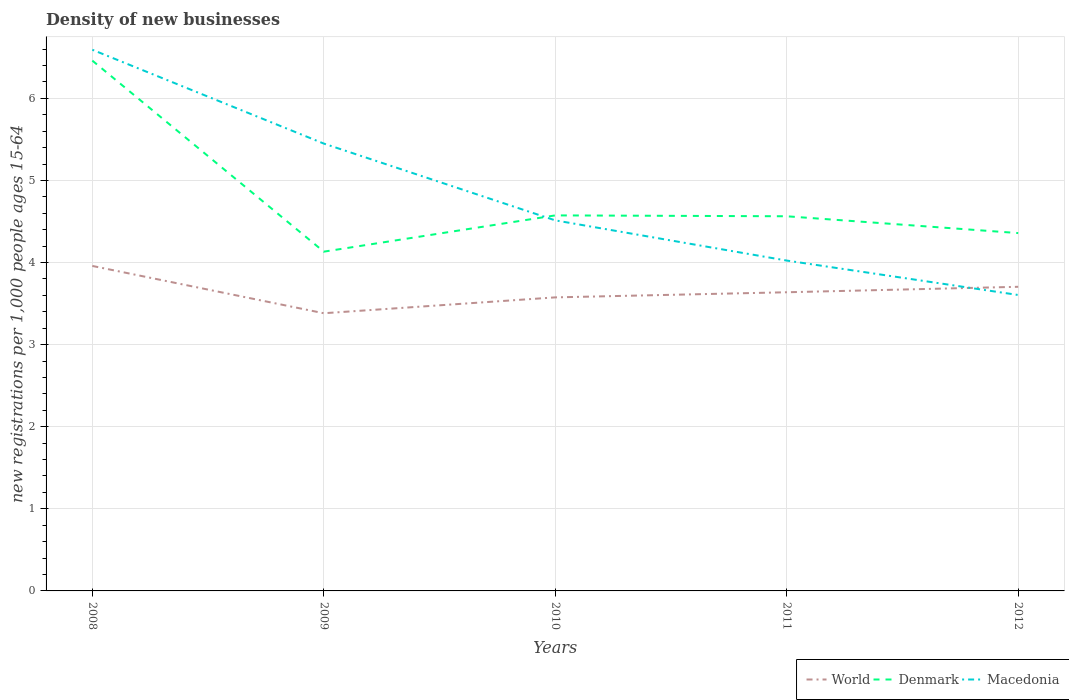How many different coloured lines are there?
Offer a terse response. 3. Does the line corresponding to World intersect with the line corresponding to Denmark?
Give a very brief answer. No. Is the number of lines equal to the number of legend labels?
Provide a succinct answer. Yes. Across all years, what is the maximum number of new registrations in World?
Provide a short and direct response. 3.38. In which year was the number of new registrations in Denmark maximum?
Your answer should be very brief. 2009. What is the total number of new registrations in Denmark in the graph?
Offer a very short reply. -0.23. What is the difference between the highest and the second highest number of new registrations in Denmark?
Keep it short and to the point. 2.33. What is the difference between the highest and the lowest number of new registrations in Macedonia?
Your answer should be compact. 2. What is the difference between two consecutive major ticks on the Y-axis?
Provide a short and direct response. 1. Are the values on the major ticks of Y-axis written in scientific E-notation?
Provide a succinct answer. No. Does the graph contain grids?
Keep it short and to the point. Yes. Where does the legend appear in the graph?
Provide a short and direct response. Bottom right. How many legend labels are there?
Offer a very short reply. 3. What is the title of the graph?
Make the answer very short. Density of new businesses. What is the label or title of the Y-axis?
Your answer should be very brief. New registrations per 1,0 people ages 15-64. What is the new registrations per 1,000 people ages 15-64 of World in 2008?
Provide a short and direct response. 3.96. What is the new registrations per 1,000 people ages 15-64 in Denmark in 2008?
Make the answer very short. 6.46. What is the new registrations per 1,000 people ages 15-64 of Macedonia in 2008?
Offer a terse response. 6.59. What is the new registrations per 1,000 people ages 15-64 in World in 2009?
Give a very brief answer. 3.38. What is the new registrations per 1,000 people ages 15-64 in Denmark in 2009?
Ensure brevity in your answer.  4.13. What is the new registrations per 1,000 people ages 15-64 of Macedonia in 2009?
Your response must be concise. 5.45. What is the new registrations per 1,000 people ages 15-64 of World in 2010?
Provide a succinct answer. 3.58. What is the new registrations per 1,000 people ages 15-64 in Denmark in 2010?
Keep it short and to the point. 4.57. What is the new registrations per 1,000 people ages 15-64 of Macedonia in 2010?
Offer a terse response. 4.51. What is the new registrations per 1,000 people ages 15-64 in World in 2011?
Give a very brief answer. 3.64. What is the new registrations per 1,000 people ages 15-64 of Denmark in 2011?
Provide a short and direct response. 4.56. What is the new registrations per 1,000 people ages 15-64 of Macedonia in 2011?
Your answer should be very brief. 4.02. What is the new registrations per 1,000 people ages 15-64 in World in 2012?
Give a very brief answer. 3.7. What is the new registrations per 1,000 people ages 15-64 in Denmark in 2012?
Offer a terse response. 4.36. What is the new registrations per 1,000 people ages 15-64 in Macedonia in 2012?
Your response must be concise. 3.6. Across all years, what is the maximum new registrations per 1,000 people ages 15-64 of World?
Make the answer very short. 3.96. Across all years, what is the maximum new registrations per 1,000 people ages 15-64 of Denmark?
Provide a short and direct response. 6.46. Across all years, what is the maximum new registrations per 1,000 people ages 15-64 of Macedonia?
Your answer should be very brief. 6.59. Across all years, what is the minimum new registrations per 1,000 people ages 15-64 in World?
Your answer should be compact. 3.38. Across all years, what is the minimum new registrations per 1,000 people ages 15-64 in Denmark?
Provide a succinct answer. 4.13. Across all years, what is the minimum new registrations per 1,000 people ages 15-64 of Macedonia?
Provide a succinct answer. 3.6. What is the total new registrations per 1,000 people ages 15-64 of World in the graph?
Offer a very short reply. 18.26. What is the total new registrations per 1,000 people ages 15-64 of Denmark in the graph?
Ensure brevity in your answer.  24.09. What is the total new registrations per 1,000 people ages 15-64 of Macedonia in the graph?
Ensure brevity in your answer.  24.18. What is the difference between the new registrations per 1,000 people ages 15-64 of World in 2008 and that in 2009?
Give a very brief answer. 0.58. What is the difference between the new registrations per 1,000 people ages 15-64 in Denmark in 2008 and that in 2009?
Provide a succinct answer. 2.33. What is the difference between the new registrations per 1,000 people ages 15-64 of Macedonia in 2008 and that in 2009?
Your answer should be compact. 1.14. What is the difference between the new registrations per 1,000 people ages 15-64 of World in 2008 and that in 2010?
Keep it short and to the point. 0.38. What is the difference between the new registrations per 1,000 people ages 15-64 of Denmark in 2008 and that in 2010?
Provide a succinct answer. 1.89. What is the difference between the new registrations per 1,000 people ages 15-64 in Macedonia in 2008 and that in 2010?
Make the answer very short. 2.08. What is the difference between the new registrations per 1,000 people ages 15-64 of World in 2008 and that in 2011?
Offer a very short reply. 0.32. What is the difference between the new registrations per 1,000 people ages 15-64 of Denmark in 2008 and that in 2011?
Give a very brief answer. 1.9. What is the difference between the new registrations per 1,000 people ages 15-64 in Macedonia in 2008 and that in 2011?
Offer a very short reply. 2.57. What is the difference between the new registrations per 1,000 people ages 15-64 in World in 2008 and that in 2012?
Keep it short and to the point. 0.25. What is the difference between the new registrations per 1,000 people ages 15-64 of Denmark in 2008 and that in 2012?
Provide a succinct answer. 2.1. What is the difference between the new registrations per 1,000 people ages 15-64 in Macedonia in 2008 and that in 2012?
Ensure brevity in your answer.  2.99. What is the difference between the new registrations per 1,000 people ages 15-64 of World in 2009 and that in 2010?
Offer a very short reply. -0.19. What is the difference between the new registrations per 1,000 people ages 15-64 of Denmark in 2009 and that in 2010?
Offer a very short reply. -0.44. What is the difference between the new registrations per 1,000 people ages 15-64 of Macedonia in 2009 and that in 2010?
Offer a very short reply. 0.94. What is the difference between the new registrations per 1,000 people ages 15-64 of World in 2009 and that in 2011?
Offer a terse response. -0.26. What is the difference between the new registrations per 1,000 people ages 15-64 in Denmark in 2009 and that in 2011?
Offer a terse response. -0.43. What is the difference between the new registrations per 1,000 people ages 15-64 of Macedonia in 2009 and that in 2011?
Offer a very short reply. 1.43. What is the difference between the new registrations per 1,000 people ages 15-64 in World in 2009 and that in 2012?
Keep it short and to the point. -0.32. What is the difference between the new registrations per 1,000 people ages 15-64 of Denmark in 2009 and that in 2012?
Offer a terse response. -0.23. What is the difference between the new registrations per 1,000 people ages 15-64 in Macedonia in 2009 and that in 2012?
Your response must be concise. 1.84. What is the difference between the new registrations per 1,000 people ages 15-64 in World in 2010 and that in 2011?
Offer a very short reply. -0.06. What is the difference between the new registrations per 1,000 people ages 15-64 of Denmark in 2010 and that in 2011?
Provide a short and direct response. 0.01. What is the difference between the new registrations per 1,000 people ages 15-64 in Macedonia in 2010 and that in 2011?
Keep it short and to the point. 0.49. What is the difference between the new registrations per 1,000 people ages 15-64 in World in 2010 and that in 2012?
Keep it short and to the point. -0.13. What is the difference between the new registrations per 1,000 people ages 15-64 of Denmark in 2010 and that in 2012?
Your answer should be compact. 0.22. What is the difference between the new registrations per 1,000 people ages 15-64 of Macedonia in 2010 and that in 2012?
Keep it short and to the point. 0.91. What is the difference between the new registrations per 1,000 people ages 15-64 of World in 2011 and that in 2012?
Your response must be concise. -0.07. What is the difference between the new registrations per 1,000 people ages 15-64 in Denmark in 2011 and that in 2012?
Give a very brief answer. 0.2. What is the difference between the new registrations per 1,000 people ages 15-64 of Macedonia in 2011 and that in 2012?
Your response must be concise. 0.42. What is the difference between the new registrations per 1,000 people ages 15-64 of World in 2008 and the new registrations per 1,000 people ages 15-64 of Denmark in 2009?
Provide a short and direct response. -0.17. What is the difference between the new registrations per 1,000 people ages 15-64 in World in 2008 and the new registrations per 1,000 people ages 15-64 in Macedonia in 2009?
Offer a very short reply. -1.49. What is the difference between the new registrations per 1,000 people ages 15-64 in Denmark in 2008 and the new registrations per 1,000 people ages 15-64 in Macedonia in 2009?
Keep it short and to the point. 1.01. What is the difference between the new registrations per 1,000 people ages 15-64 in World in 2008 and the new registrations per 1,000 people ages 15-64 in Denmark in 2010?
Your answer should be compact. -0.62. What is the difference between the new registrations per 1,000 people ages 15-64 in World in 2008 and the new registrations per 1,000 people ages 15-64 in Macedonia in 2010?
Make the answer very short. -0.56. What is the difference between the new registrations per 1,000 people ages 15-64 in Denmark in 2008 and the new registrations per 1,000 people ages 15-64 in Macedonia in 2010?
Give a very brief answer. 1.95. What is the difference between the new registrations per 1,000 people ages 15-64 in World in 2008 and the new registrations per 1,000 people ages 15-64 in Denmark in 2011?
Offer a terse response. -0.6. What is the difference between the new registrations per 1,000 people ages 15-64 in World in 2008 and the new registrations per 1,000 people ages 15-64 in Macedonia in 2011?
Your answer should be compact. -0.07. What is the difference between the new registrations per 1,000 people ages 15-64 of Denmark in 2008 and the new registrations per 1,000 people ages 15-64 of Macedonia in 2011?
Give a very brief answer. 2.44. What is the difference between the new registrations per 1,000 people ages 15-64 in World in 2008 and the new registrations per 1,000 people ages 15-64 in Denmark in 2012?
Provide a succinct answer. -0.4. What is the difference between the new registrations per 1,000 people ages 15-64 in World in 2008 and the new registrations per 1,000 people ages 15-64 in Macedonia in 2012?
Give a very brief answer. 0.35. What is the difference between the new registrations per 1,000 people ages 15-64 of Denmark in 2008 and the new registrations per 1,000 people ages 15-64 of Macedonia in 2012?
Offer a terse response. 2.86. What is the difference between the new registrations per 1,000 people ages 15-64 of World in 2009 and the new registrations per 1,000 people ages 15-64 of Denmark in 2010?
Your response must be concise. -1.19. What is the difference between the new registrations per 1,000 people ages 15-64 of World in 2009 and the new registrations per 1,000 people ages 15-64 of Macedonia in 2010?
Offer a very short reply. -1.13. What is the difference between the new registrations per 1,000 people ages 15-64 in Denmark in 2009 and the new registrations per 1,000 people ages 15-64 in Macedonia in 2010?
Make the answer very short. -0.38. What is the difference between the new registrations per 1,000 people ages 15-64 in World in 2009 and the new registrations per 1,000 people ages 15-64 in Denmark in 2011?
Offer a terse response. -1.18. What is the difference between the new registrations per 1,000 people ages 15-64 of World in 2009 and the new registrations per 1,000 people ages 15-64 of Macedonia in 2011?
Offer a terse response. -0.64. What is the difference between the new registrations per 1,000 people ages 15-64 of Denmark in 2009 and the new registrations per 1,000 people ages 15-64 of Macedonia in 2011?
Your response must be concise. 0.11. What is the difference between the new registrations per 1,000 people ages 15-64 of World in 2009 and the new registrations per 1,000 people ages 15-64 of Denmark in 2012?
Provide a succinct answer. -0.98. What is the difference between the new registrations per 1,000 people ages 15-64 in World in 2009 and the new registrations per 1,000 people ages 15-64 in Macedonia in 2012?
Offer a terse response. -0.22. What is the difference between the new registrations per 1,000 people ages 15-64 of Denmark in 2009 and the new registrations per 1,000 people ages 15-64 of Macedonia in 2012?
Give a very brief answer. 0.53. What is the difference between the new registrations per 1,000 people ages 15-64 in World in 2010 and the new registrations per 1,000 people ages 15-64 in Denmark in 2011?
Provide a short and direct response. -0.99. What is the difference between the new registrations per 1,000 people ages 15-64 in World in 2010 and the new registrations per 1,000 people ages 15-64 in Macedonia in 2011?
Keep it short and to the point. -0.45. What is the difference between the new registrations per 1,000 people ages 15-64 of Denmark in 2010 and the new registrations per 1,000 people ages 15-64 of Macedonia in 2011?
Provide a short and direct response. 0.55. What is the difference between the new registrations per 1,000 people ages 15-64 in World in 2010 and the new registrations per 1,000 people ages 15-64 in Denmark in 2012?
Keep it short and to the point. -0.78. What is the difference between the new registrations per 1,000 people ages 15-64 in World in 2010 and the new registrations per 1,000 people ages 15-64 in Macedonia in 2012?
Ensure brevity in your answer.  -0.03. What is the difference between the new registrations per 1,000 people ages 15-64 of Denmark in 2010 and the new registrations per 1,000 people ages 15-64 of Macedonia in 2012?
Offer a terse response. 0.97. What is the difference between the new registrations per 1,000 people ages 15-64 of World in 2011 and the new registrations per 1,000 people ages 15-64 of Denmark in 2012?
Offer a very short reply. -0.72. What is the difference between the new registrations per 1,000 people ages 15-64 of Denmark in 2011 and the new registrations per 1,000 people ages 15-64 of Macedonia in 2012?
Your answer should be very brief. 0.96. What is the average new registrations per 1,000 people ages 15-64 in World per year?
Give a very brief answer. 3.65. What is the average new registrations per 1,000 people ages 15-64 of Denmark per year?
Give a very brief answer. 4.82. What is the average new registrations per 1,000 people ages 15-64 of Macedonia per year?
Offer a terse response. 4.84. In the year 2008, what is the difference between the new registrations per 1,000 people ages 15-64 of World and new registrations per 1,000 people ages 15-64 of Denmark?
Provide a succinct answer. -2.5. In the year 2008, what is the difference between the new registrations per 1,000 people ages 15-64 in World and new registrations per 1,000 people ages 15-64 in Macedonia?
Ensure brevity in your answer.  -2.63. In the year 2008, what is the difference between the new registrations per 1,000 people ages 15-64 of Denmark and new registrations per 1,000 people ages 15-64 of Macedonia?
Your response must be concise. -0.13. In the year 2009, what is the difference between the new registrations per 1,000 people ages 15-64 in World and new registrations per 1,000 people ages 15-64 in Denmark?
Your answer should be very brief. -0.75. In the year 2009, what is the difference between the new registrations per 1,000 people ages 15-64 of World and new registrations per 1,000 people ages 15-64 of Macedonia?
Offer a very short reply. -2.07. In the year 2009, what is the difference between the new registrations per 1,000 people ages 15-64 in Denmark and new registrations per 1,000 people ages 15-64 in Macedonia?
Provide a short and direct response. -1.32. In the year 2010, what is the difference between the new registrations per 1,000 people ages 15-64 of World and new registrations per 1,000 people ages 15-64 of Denmark?
Give a very brief answer. -1. In the year 2010, what is the difference between the new registrations per 1,000 people ages 15-64 of World and new registrations per 1,000 people ages 15-64 of Macedonia?
Offer a terse response. -0.94. In the year 2010, what is the difference between the new registrations per 1,000 people ages 15-64 in Denmark and new registrations per 1,000 people ages 15-64 in Macedonia?
Make the answer very short. 0.06. In the year 2011, what is the difference between the new registrations per 1,000 people ages 15-64 in World and new registrations per 1,000 people ages 15-64 in Denmark?
Your response must be concise. -0.93. In the year 2011, what is the difference between the new registrations per 1,000 people ages 15-64 of World and new registrations per 1,000 people ages 15-64 of Macedonia?
Provide a short and direct response. -0.39. In the year 2011, what is the difference between the new registrations per 1,000 people ages 15-64 of Denmark and new registrations per 1,000 people ages 15-64 of Macedonia?
Offer a terse response. 0.54. In the year 2012, what is the difference between the new registrations per 1,000 people ages 15-64 of World and new registrations per 1,000 people ages 15-64 of Denmark?
Provide a succinct answer. -0.65. In the year 2012, what is the difference between the new registrations per 1,000 people ages 15-64 of Denmark and new registrations per 1,000 people ages 15-64 of Macedonia?
Ensure brevity in your answer.  0.75. What is the ratio of the new registrations per 1,000 people ages 15-64 in World in 2008 to that in 2009?
Your response must be concise. 1.17. What is the ratio of the new registrations per 1,000 people ages 15-64 of Denmark in 2008 to that in 2009?
Your answer should be very brief. 1.56. What is the ratio of the new registrations per 1,000 people ages 15-64 of Macedonia in 2008 to that in 2009?
Provide a succinct answer. 1.21. What is the ratio of the new registrations per 1,000 people ages 15-64 of World in 2008 to that in 2010?
Provide a succinct answer. 1.11. What is the ratio of the new registrations per 1,000 people ages 15-64 in Denmark in 2008 to that in 2010?
Provide a short and direct response. 1.41. What is the ratio of the new registrations per 1,000 people ages 15-64 of Macedonia in 2008 to that in 2010?
Provide a short and direct response. 1.46. What is the ratio of the new registrations per 1,000 people ages 15-64 in World in 2008 to that in 2011?
Make the answer very short. 1.09. What is the ratio of the new registrations per 1,000 people ages 15-64 of Denmark in 2008 to that in 2011?
Make the answer very short. 1.42. What is the ratio of the new registrations per 1,000 people ages 15-64 in Macedonia in 2008 to that in 2011?
Keep it short and to the point. 1.64. What is the ratio of the new registrations per 1,000 people ages 15-64 of World in 2008 to that in 2012?
Keep it short and to the point. 1.07. What is the ratio of the new registrations per 1,000 people ages 15-64 in Denmark in 2008 to that in 2012?
Make the answer very short. 1.48. What is the ratio of the new registrations per 1,000 people ages 15-64 in Macedonia in 2008 to that in 2012?
Provide a succinct answer. 1.83. What is the ratio of the new registrations per 1,000 people ages 15-64 in World in 2009 to that in 2010?
Your answer should be compact. 0.95. What is the ratio of the new registrations per 1,000 people ages 15-64 in Denmark in 2009 to that in 2010?
Keep it short and to the point. 0.9. What is the ratio of the new registrations per 1,000 people ages 15-64 of Macedonia in 2009 to that in 2010?
Provide a succinct answer. 1.21. What is the ratio of the new registrations per 1,000 people ages 15-64 of World in 2009 to that in 2011?
Provide a short and direct response. 0.93. What is the ratio of the new registrations per 1,000 people ages 15-64 in Denmark in 2009 to that in 2011?
Give a very brief answer. 0.91. What is the ratio of the new registrations per 1,000 people ages 15-64 in Macedonia in 2009 to that in 2011?
Your answer should be compact. 1.35. What is the ratio of the new registrations per 1,000 people ages 15-64 in Denmark in 2009 to that in 2012?
Provide a succinct answer. 0.95. What is the ratio of the new registrations per 1,000 people ages 15-64 in Macedonia in 2009 to that in 2012?
Keep it short and to the point. 1.51. What is the ratio of the new registrations per 1,000 people ages 15-64 in World in 2010 to that in 2011?
Your answer should be compact. 0.98. What is the ratio of the new registrations per 1,000 people ages 15-64 in Denmark in 2010 to that in 2011?
Offer a very short reply. 1. What is the ratio of the new registrations per 1,000 people ages 15-64 of Macedonia in 2010 to that in 2011?
Make the answer very short. 1.12. What is the ratio of the new registrations per 1,000 people ages 15-64 of World in 2010 to that in 2012?
Provide a short and direct response. 0.97. What is the ratio of the new registrations per 1,000 people ages 15-64 of Denmark in 2010 to that in 2012?
Give a very brief answer. 1.05. What is the ratio of the new registrations per 1,000 people ages 15-64 of Macedonia in 2010 to that in 2012?
Provide a short and direct response. 1.25. What is the ratio of the new registrations per 1,000 people ages 15-64 of World in 2011 to that in 2012?
Offer a very short reply. 0.98. What is the ratio of the new registrations per 1,000 people ages 15-64 in Denmark in 2011 to that in 2012?
Make the answer very short. 1.05. What is the ratio of the new registrations per 1,000 people ages 15-64 in Macedonia in 2011 to that in 2012?
Ensure brevity in your answer.  1.12. What is the difference between the highest and the second highest new registrations per 1,000 people ages 15-64 in World?
Provide a succinct answer. 0.25. What is the difference between the highest and the second highest new registrations per 1,000 people ages 15-64 in Denmark?
Offer a very short reply. 1.89. What is the difference between the highest and the second highest new registrations per 1,000 people ages 15-64 of Macedonia?
Keep it short and to the point. 1.14. What is the difference between the highest and the lowest new registrations per 1,000 people ages 15-64 in World?
Ensure brevity in your answer.  0.58. What is the difference between the highest and the lowest new registrations per 1,000 people ages 15-64 in Denmark?
Your response must be concise. 2.33. What is the difference between the highest and the lowest new registrations per 1,000 people ages 15-64 in Macedonia?
Offer a very short reply. 2.99. 